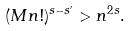Convert formula to latex. <formula><loc_0><loc_0><loc_500><loc_500>( M n ! ) ^ { s - s ^ { \prime } } > n ^ { 2 s } .</formula> 